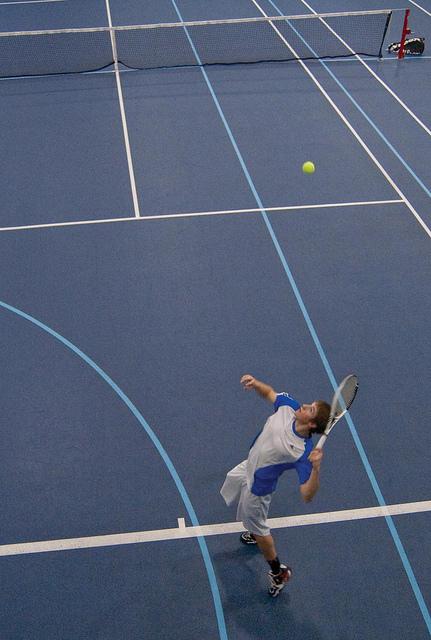Is the ball falling or rising?
Short answer required. Falling. What color is the player's shirt?
Short answer required. White and blue. What is the other color strip that is not white?
Short answer required. Blue. 